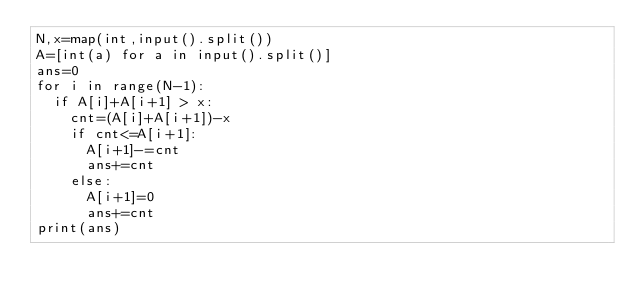<code> <loc_0><loc_0><loc_500><loc_500><_Python_>N,x=map(int,input().split())
A=[int(a) for a in input().split()]
ans=0
for i in range(N-1):
  if A[i]+A[i+1] > x:
    cnt=(A[i]+A[i+1])-x
    if cnt<=A[i+1]:
      A[i+1]-=cnt
      ans+=cnt
    else:
      A[i+1]=0
      ans+=cnt
print(ans)</code> 